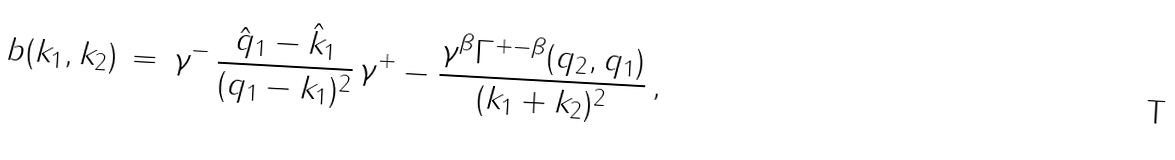<formula> <loc_0><loc_0><loc_500><loc_500>b ( k _ { 1 } , k _ { 2 } ) \, = \, \gamma ^ { - } \, \frac { \hat { q } _ { 1 } - \hat { k } _ { 1 } } { ( q _ { 1 } - k _ { 1 } ) ^ { 2 } } \, \gamma ^ { + } - \frac { \gamma ^ { \beta } \Gamma ^ { + - \beta } ( q _ { 2 } , q _ { 1 } ) } { ( k _ { 1 } + k _ { 2 } ) ^ { 2 } } \, ,</formula> 